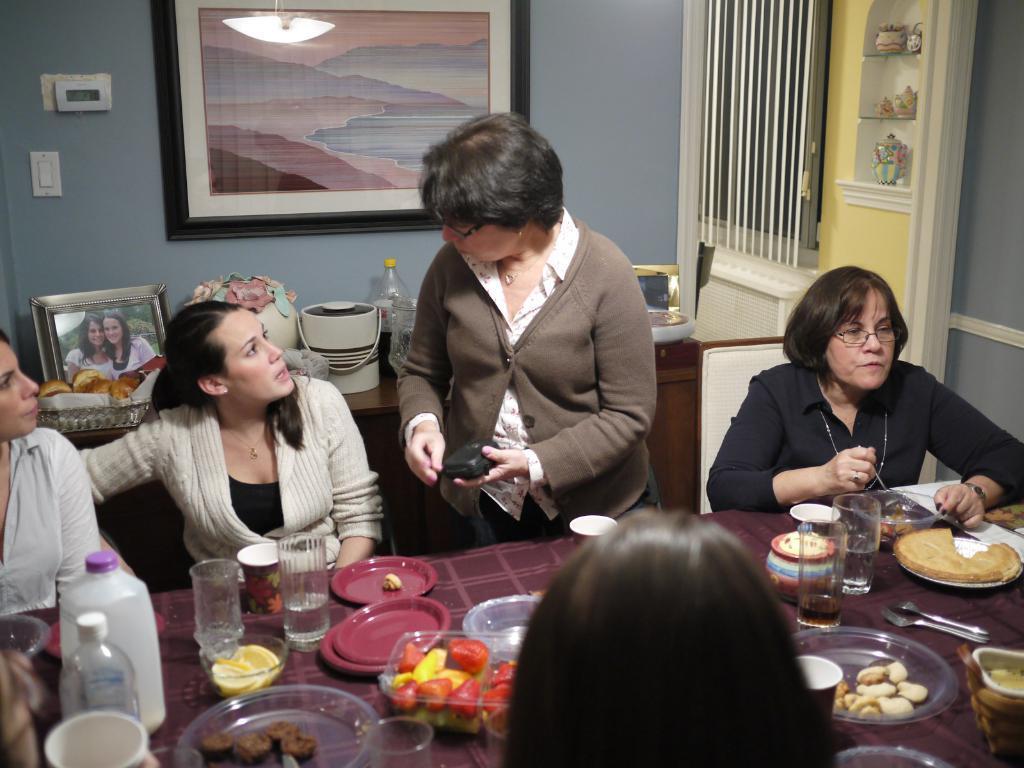Could you give a brief overview of what you see in this image? This picture shows that there are five persons in the room. Out of which four are sitting on the chair and one person is standing and talking in front of the table on which plates, bowls, glasses, food items, jar and son kept. The background wall is ash in color on which wall painting is there. Behind that a table is there on which photo frame, flower vase, bottle and soon kept. And a rack is there in the middle and having a wall of yellow in color. And a window visible having a curtain blank on it. This image is taken inside a room. 